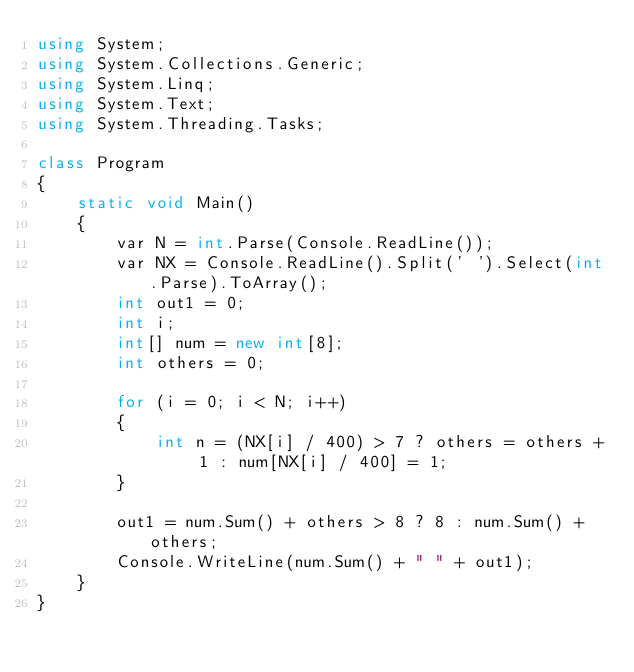<code> <loc_0><loc_0><loc_500><loc_500><_C#_>using System;
using System.Collections.Generic;
using System.Linq;
using System.Text;
using System.Threading.Tasks;

class Program
{
    static void Main()
    {
        var N = int.Parse(Console.ReadLine());
        var NX = Console.ReadLine().Split(' ').Select(int.Parse).ToArray();
        int out1 = 0;
        int i;
        int[] num = new int[8];
        int others = 0;

        for (i = 0; i < N; i++)
        {  
            int n = (NX[i] / 400) > 7 ? others = others + 1 : num[NX[i] / 400] = 1;
        }

        out1 = num.Sum() + others > 8 ? 8 : num.Sum() + others;
        Console.WriteLine(num.Sum() + " " + out1);
    }
}</code> 